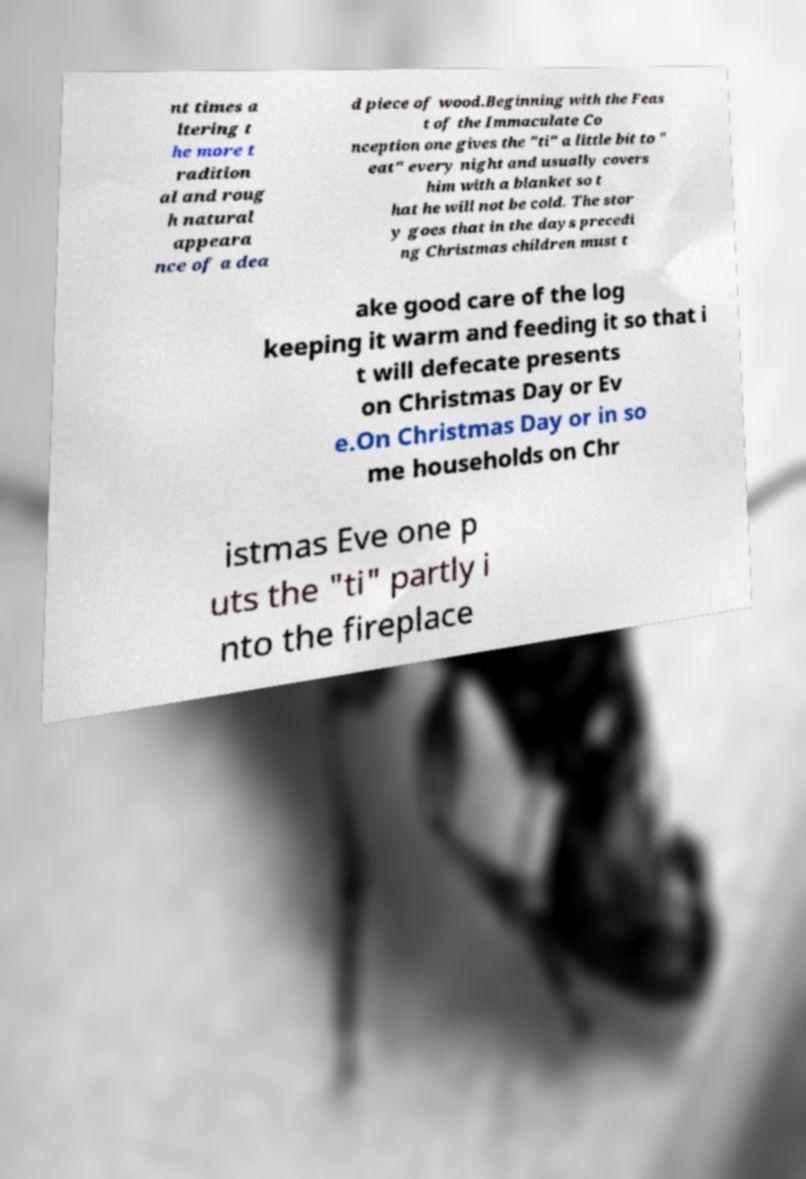Could you assist in decoding the text presented in this image and type it out clearly? nt times a ltering t he more t radition al and roug h natural appeara nce of a dea d piece of wood.Beginning with the Feas t of the Immaculate Co nception one gives the "ti" a little bit to " eat" every night and usually covers him with a blanket so t hat he will not be cold. The stor y goes that in the days precedi ng Christmas children must t ake good care of the log keeping it warm and feeding it so that i t will defecate presents on Christmas Day or Ev e.On Christmas Day or in so me households on Chr istmas Eve one p uts the "ti" partly i nto the fireplace 